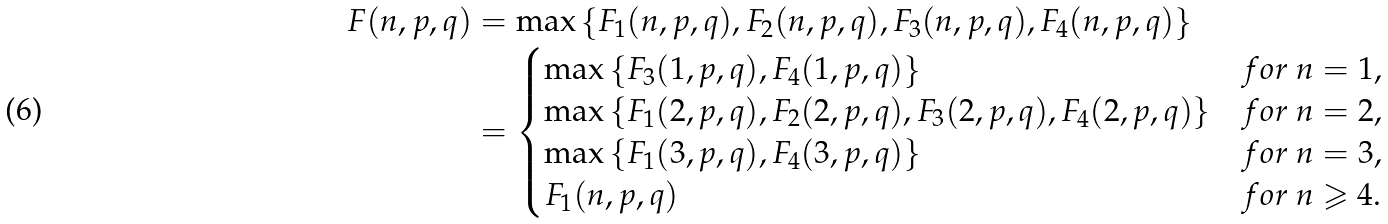<formula> <loc_0><loc_0><loc_500><loc_500>F ( n , p , q ) & = \max \left \{ F _ { 1 } ( n , p , q ) , F _ { 2 } ( n , p , q ) , F _ { 3 } ( n , p , q ) , F _ { 4 } ( n , p , q ) \right \} \\ & = \begin{cases} \max \left \{ F _ { 3 } ( 1 , p , q ) , F _ { 4 } ( 1 , p , q ) \right \} & f o r \ n = 1 , \\ \max \left \{ F _ { 1 } ( 2 , p , q ) , F _ { 2 } ( 2 , p , q ) , F _ { 3 } ( 2 , p , q ) , F _ { 4 } ( 2 , p , q ) \right \} & f o r \ n = 2 , \\ \max \left \{ F _ { 1 } ( 3 , p , q ) , F _ { 4 } ( 3 , p , q ) \right \} & f o r \ n = 3 , \\ F _ { 1 } ( n , p , q ) & f o r \ n \geqslant 4 . \end{cases}</formula> 